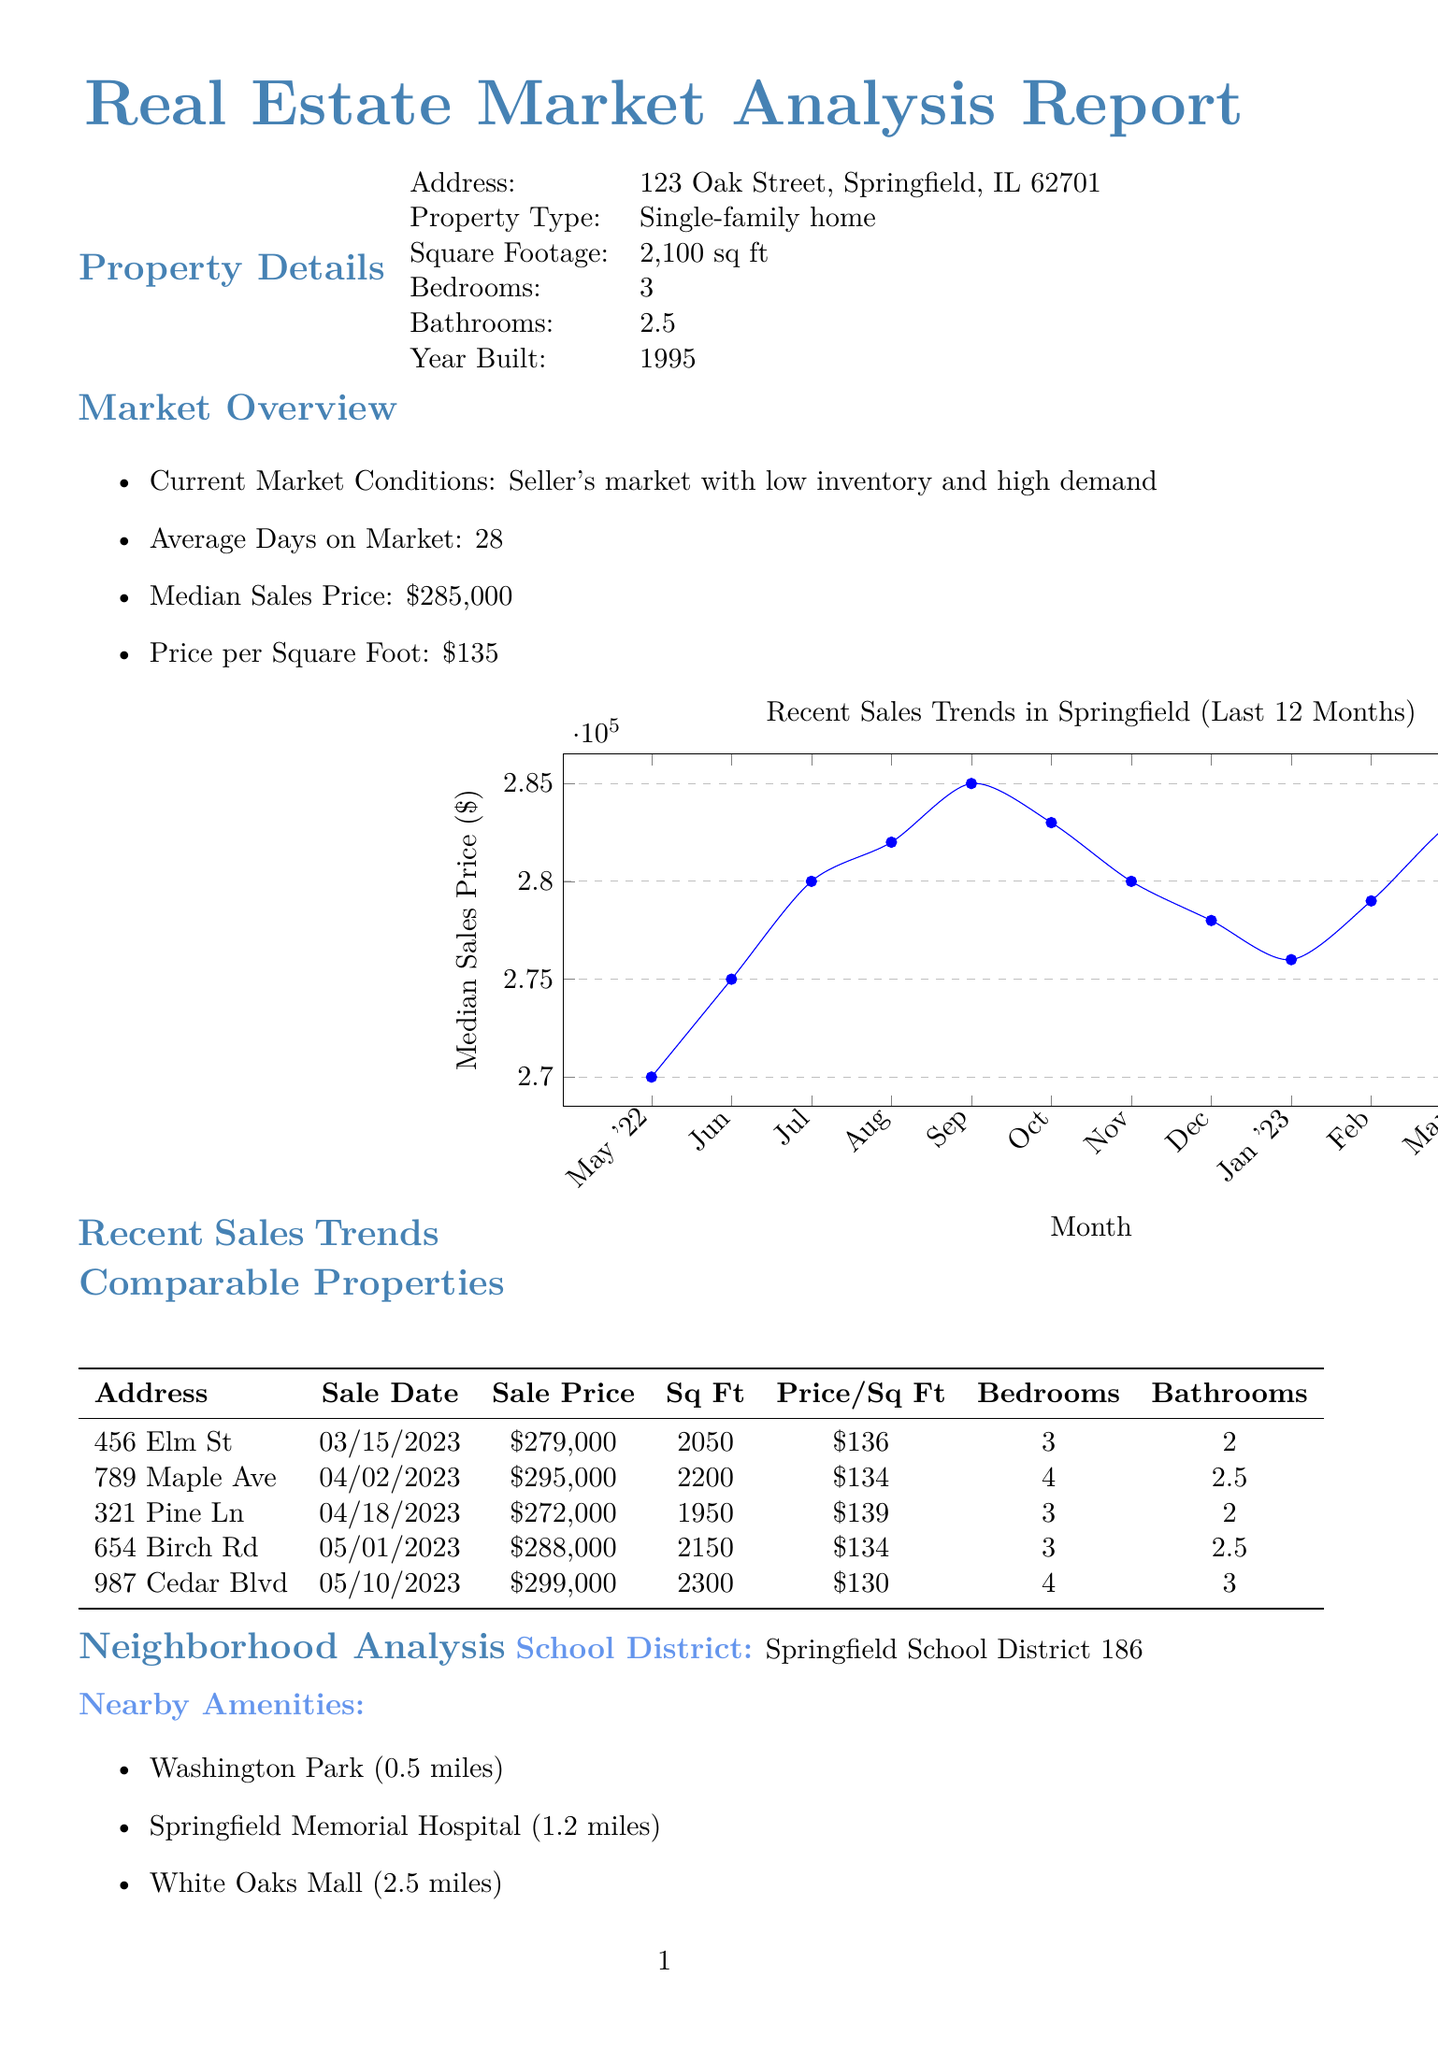what is the address of the property? The address of the property is stated in the property details section of the document as 123 Oak Street, Springfield, IL 62701.
Answer: 123 Oak Street, Springfield, IL 62701 what is the median sales price in the current market? The median sales price is provided in the market overview section of the document, indicating the current value in the market.
Answer: $285,000 how many comparable properties are listed? The number of comparable properties can be found in the comparable properties section, which lists the sold properties for reference.
Answer: 5 what is the projected price growth for 2024? The projected price growth is outlined in the market predictions section, detailing the expected annual change in property value.
Answer: 2.8 what is the average days on market? The document specifies how long properties typically stay on the market, giving an insight into market activity.
Answer: 28 who is the appraiser named in the conclusion? The appraiser's name appears toward the end of the document in the appraisal conclusion section, indicating who did the valuation.
Answer: John Smith which school district is the property located in? The school district applicable to the neighborhood is mentioned in the neighborhood analysis section, helping buyers understand educational options.
Answer: Springfield School District 186 what is the crime rate in the neighborhood? The crime rate is provided in the neighborhood analysis section, giving insight into the safety of the area.
Answer: Low what range does the comparable properties cover? The appraisal conclusion section lists the minimum and maximum sales prices among comparable properties, helping assess market value.
Answer: $272,000 - $299,000 